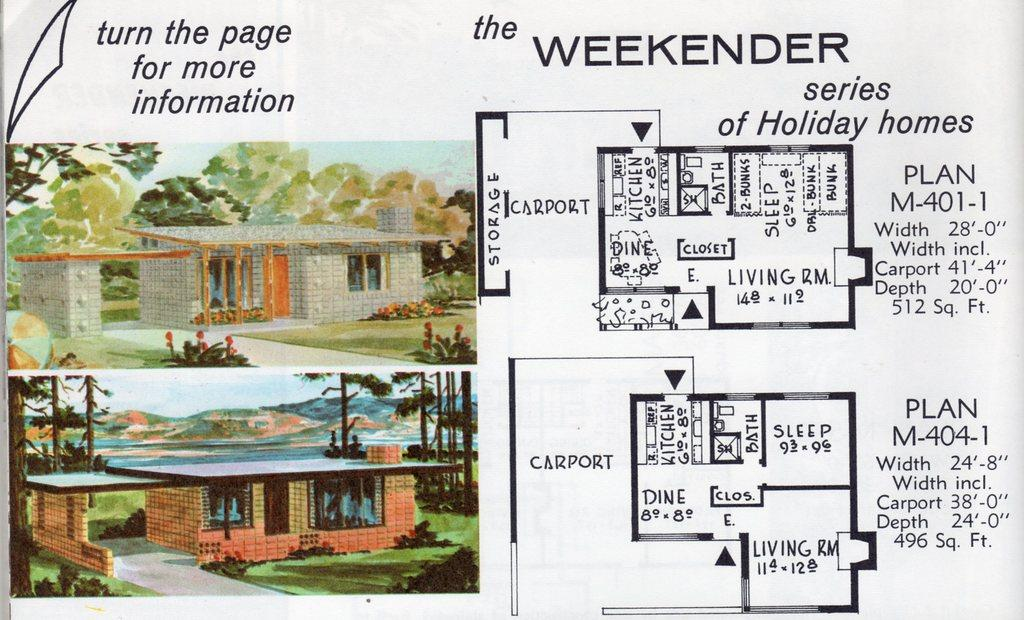<image>
Write a terse but informative summary of the picture. A flyer from the Weekender series of Holiday homes is shown. 